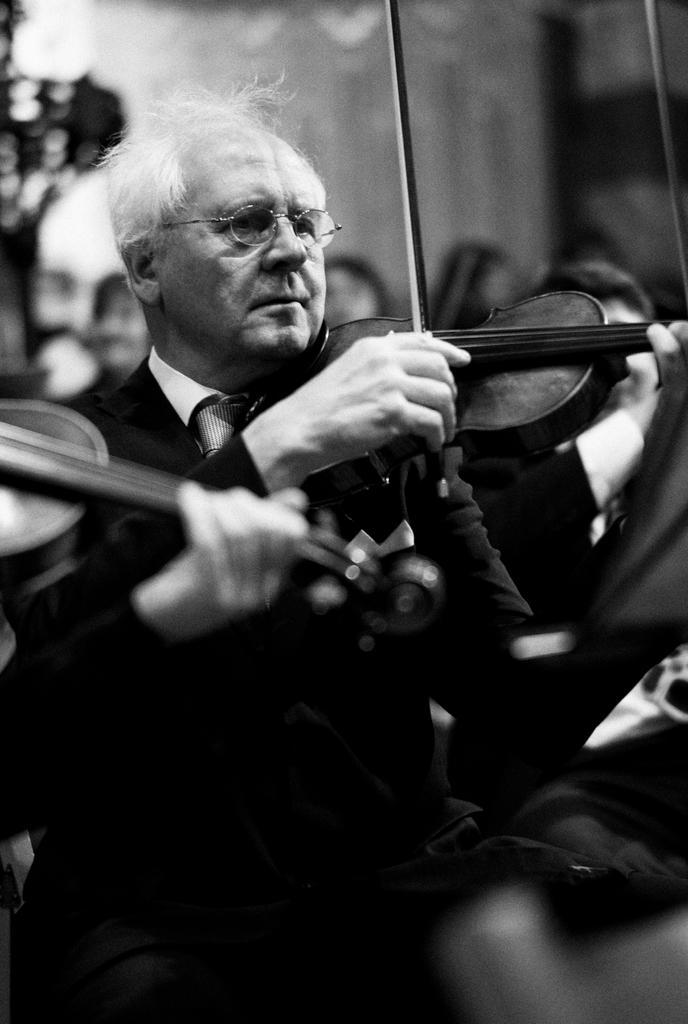Could you give a brief overview of what you see in this image? In this picture, we see a man in black blazer is sitting and holding violin in his hand and he is playing it. He wore spectacles. Behind him, we see a tree and a wall. 